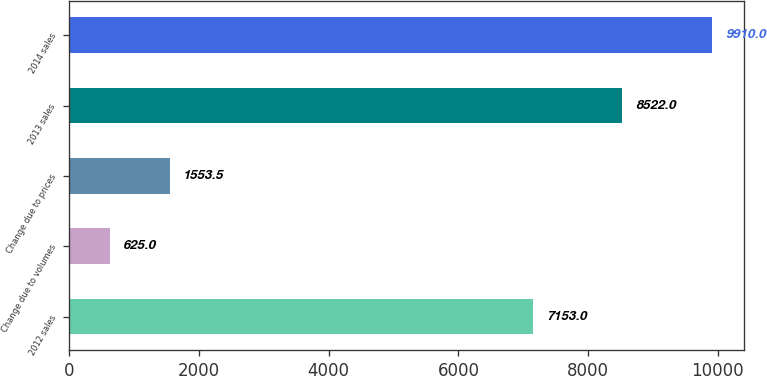Convert chart. <chart><loc_0><loc_0><loc_500><loc_500><bar_chart><fcel>2012 sales<fcel>Change due to volumes<fcel>Change due to prices<fcel>2013 sales<fcel>2014 sales<nl><fcel>7153<fcel>625<fcel>1553.5<fcel>8522<fcel>9910<nl></chart> 